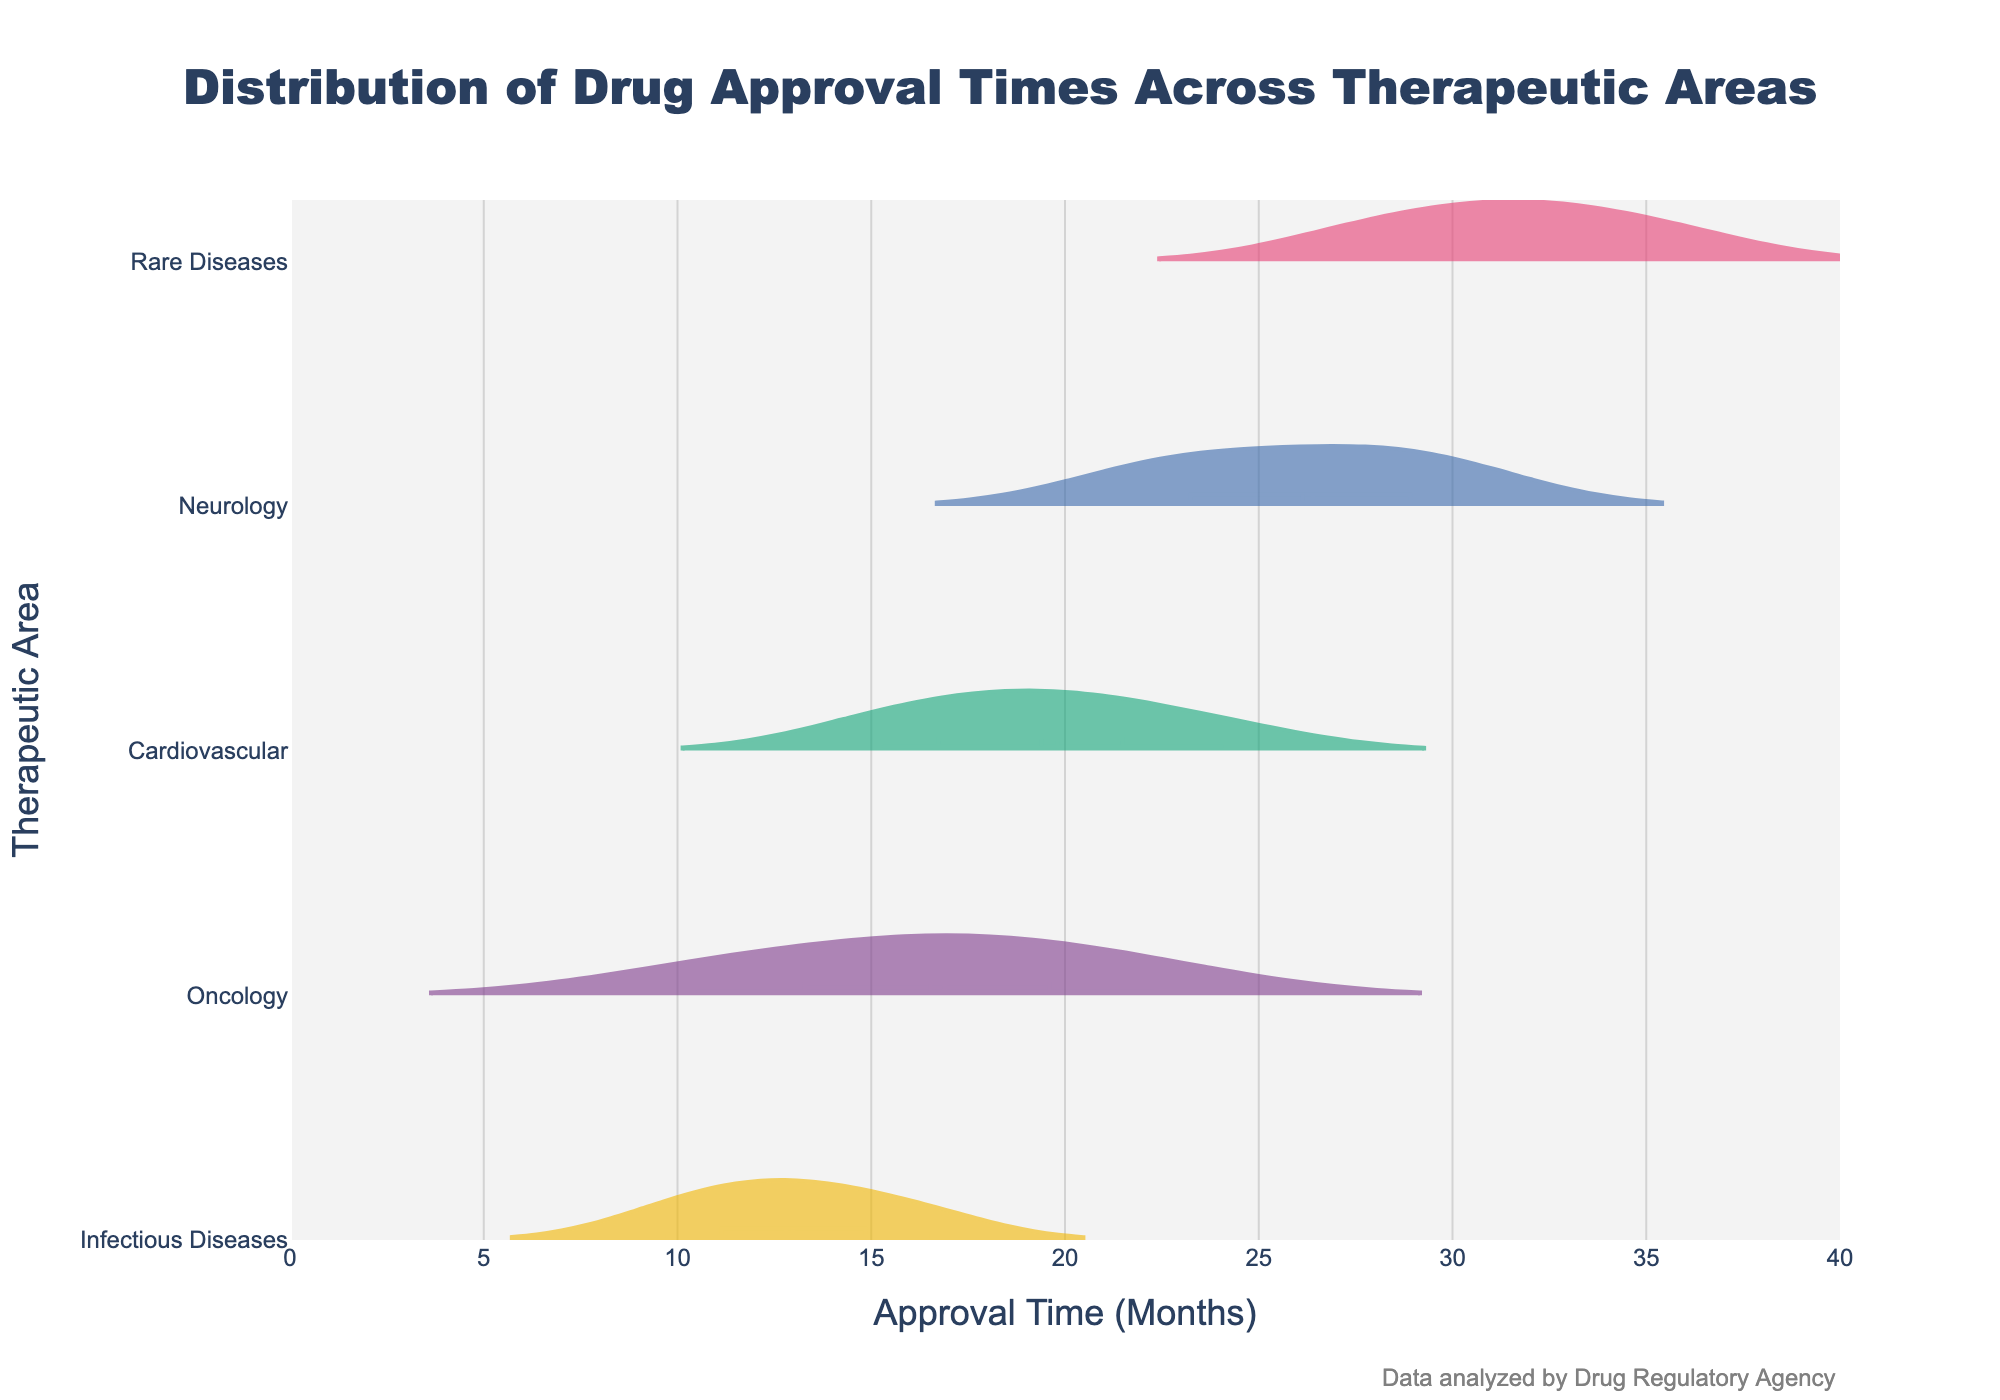What's the title of the figure? The title is usually displayed at the top of the figure and provides a summary of what the data represents.
Answer: Distribution of Drug Approval Times Across Therapeutic Areas Which therapeutic area has the highest mean approval time? The mean approval time is represented by a line in each violin plot. By comparing the positions of these lines across the therapeutic areas, we see that the line is highest for Rare Diseases.
Answer: Rare Diseases What's the range of the x-axis in the figure? The x-axis range is typically shown at the bottom, indicating the minimum and maximum values on this axis. The data points and their distribution are plotted within this range.
Answer: 0 to 40 Which therapeutic area has the smallest range of approval times? The range of approval times for each therapeutic area can be determined by the length of the violin plot along the x-axis. The shortest range is for Infectious Diseases.
Answer: Infectious Diseases What is the median approval time for the Oncology therapeutic area? The median approval time is represented by the central line within each box plot in the violin plot. By identifying the central line for Oncology, we see it is around 16.9 months.
Answer: 16.9 months Which therapeutic area has the most skewed distribution of approval times? Skewness in the data can be observed by the asymmetry of the violin plot. The therapeutic area with a visibly skewed distribution is Neurology, where there is a noticeable tilt towards longer approval times.
Answer: Neurology What's the difference between the maximum approval times for Cardiovascular and Rare Diseases? The maximum approval time can be found at the farthest point on the right of the violin plot. For Cardiovascular, it is 24.1 months, and for Rare Diseases, it is 35.9 months. Subtracting these gives 35.9 - 24.1.
Answer: 11.8 months How does the variance of approval times in Oncology compare to those of Neurology? Variance in a dataset can be visually inferred by the spread of the violin plot. Oncology has a narrower spread compared to Neurology, indicating lower variance.
Answer: Lower variance in Oncology Which therapeutic area has the most data points? The number of data points influences the density and shape of the violin plot. By estimating the density differences among the therapeutic areas, we see that all therapeutic areas have equal data points, specifically five each.
Answer: Five each What could be inferred about the drug approval process for Rare Diseases? The lengthy and spread distribution of the violin plot for Rare Diseases suggests a longer and more variable approval process compared to other areas. By analyzing the pattern, it indicates complexity and variability in the approval times.
Answer: Complex and variable approval process 